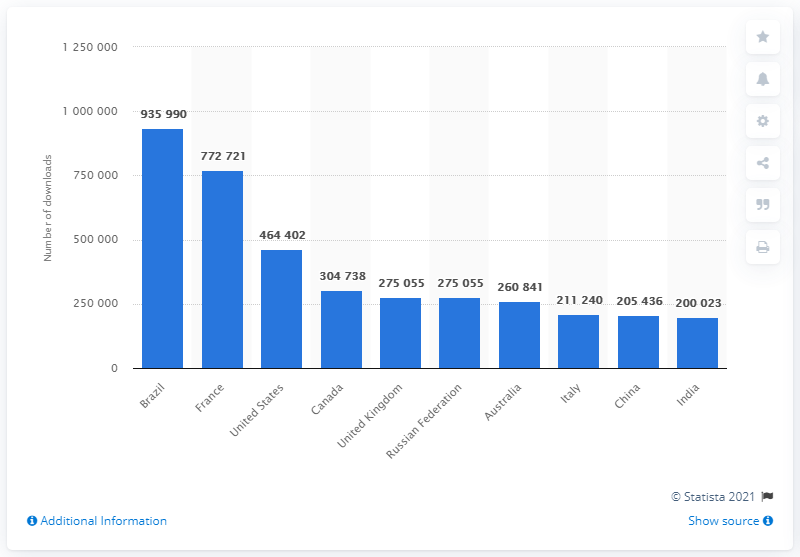Draw attention to some important aspects in this diagram. Brazil was the leading country for Game of Thrones piracy. 